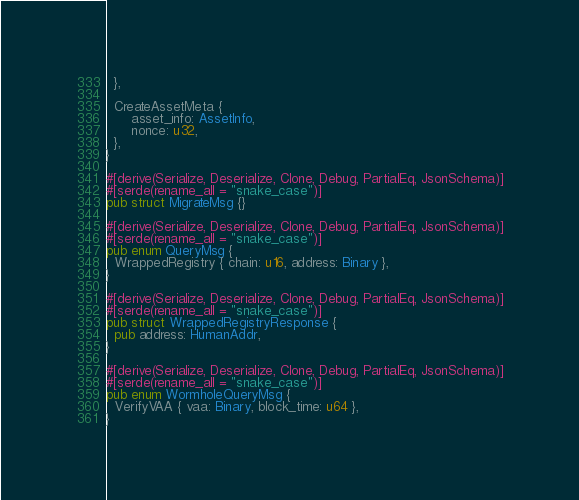Convert code to text. <code><loc_0><loc_0><loc_500><loc_500><_Rust_>  },

  CreateAssetMeta {
      asset_info: AssetInfo,
      nonce: u32,
  },
}

#[derive(Serialize, Deserialize, Clone, Debug, PartialEq, JsonSchema)]
#[serde(rename_all = "snake_case")]
pub struct MigrateMsg {}

#[derive(Serialize, Deserialize, Clone, Debug, PartialEq, JsonSchema)]
#[serde(rename_all = "snake_case")]
pub enum QueryMsg {
  WrappedRegistry { chain: u16, address: Binary },
}

#[derive(Serialize, Deserialize, Clone, Debug, PartialEq, JsonSchema)]
#[serde(rename_all = "snake_case")]
pub struct WrappedRegistryResponse {
  pub address: HumanAddr,
}

#[derive(Serialize, Deserialize, Clone, Debug, PartialEq, JsonSchema)]
#[serde(rename_all = "snake_case")]
pub enum WormholeQueryMsg {
  VerifyVAA { vaa: Binary, block_time: u64 },
}</code> 